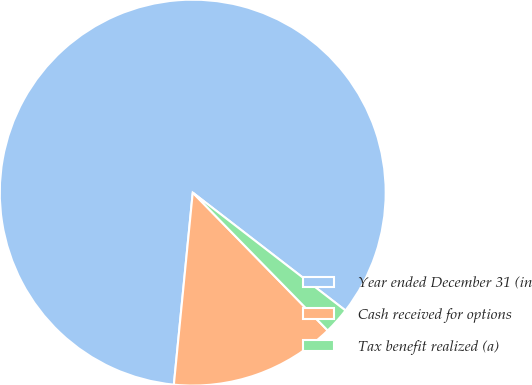Convert chart to OTSL. <chart><loc_0><loc_0><loc_500><loc_500><pie_chart><fcel>Year ended December 31 (in<fcel>Cash received for options<fcel>Tax benefit realized (a)<nl><fcel>83.9%<fcel>13.89%<fcel>2.21%<nl></chart> 